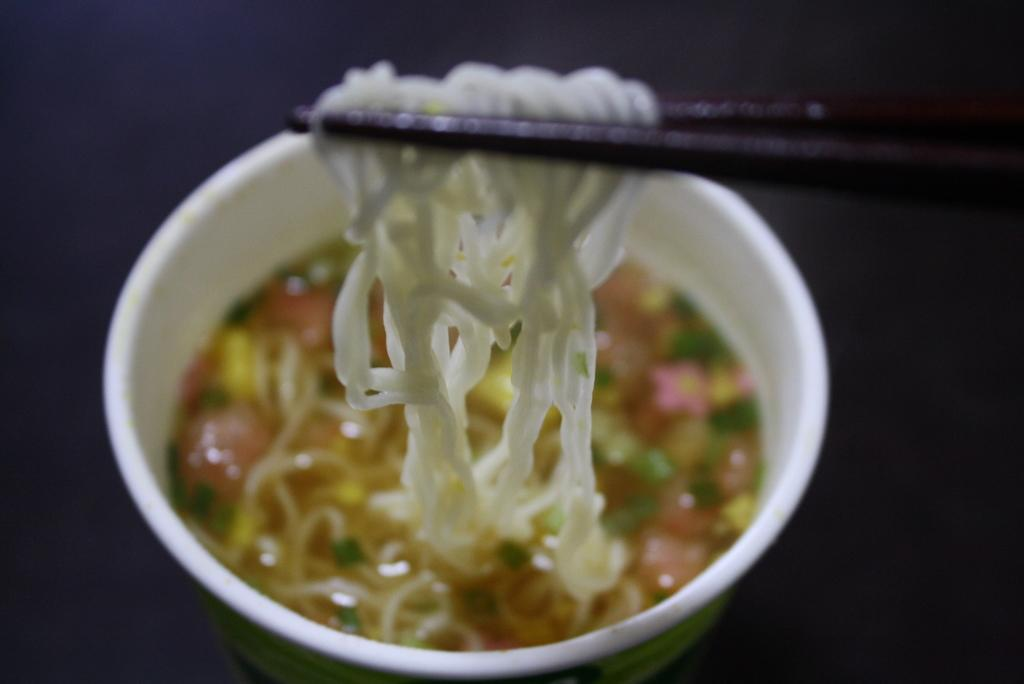What type of food is shown in the image? There are noodles in the image. What utensil is used to eat the noodles? There are chopsticks in the image. What other object is present in the image? There is a cup in the image. What action is being depicted in the image? The action of taking noodles using chopsticks is depicted in the image. What note is being played by the noodles in the image? There are no musical notes or instruments present in the image. 